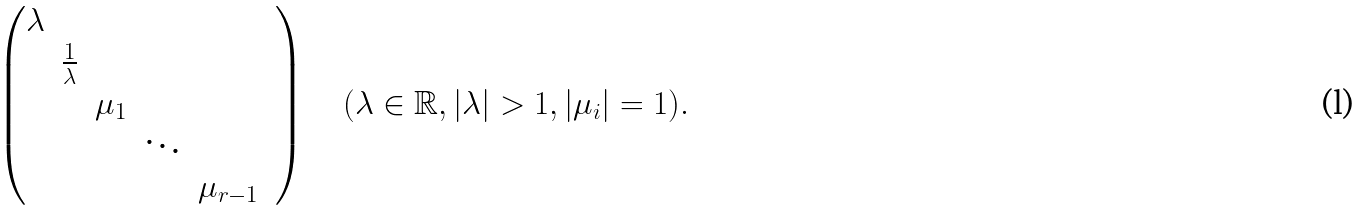Convert formula to latex. <formula><loc_0><loc_0><loc_500><loc_500>\left ( \begin{matrix} \lambda & & & & & \\ & \frac { 1 } { \lambda } & & & & \\ & & \mu _ { 1 } & & \\ & & & \ddots & \\ & & & & \mu _ { r - 1 } \end{matrix} \right ) \quad ( \lambda \in \mathbb { R } , | \lambda | > 1 , | \mu _ { i } | = 1 ) .</formula> 